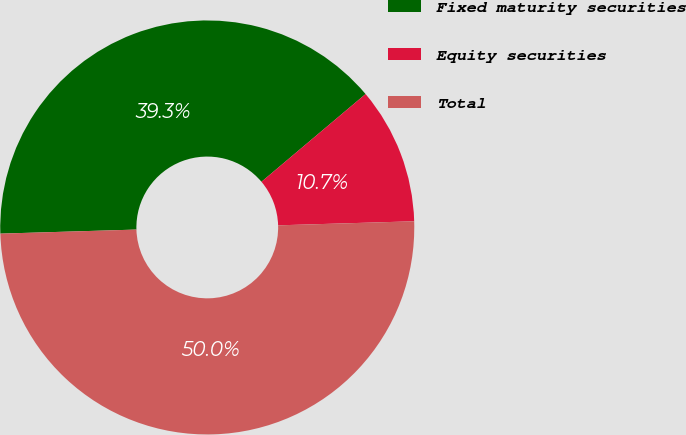<chart> <loc_0><loc_0><loc_500><loc_500><pie_chart><fcel>Fixed maturity securities<fcel>Equity securities<fcel>Total<nl><fcel>39.33%<fcel>10.67%<fcel>50.0%<nl></chart> 